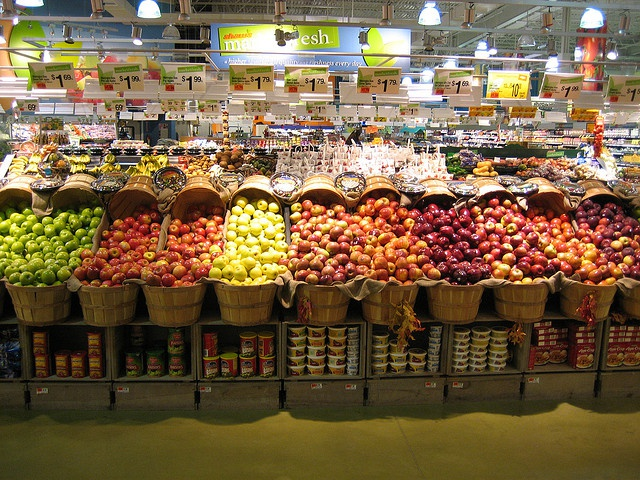Describe the objects in this image and their specific colors. I can see apple in gray, maroon, brown, and black tones, apple in gray, maroon, black, brown, and red tones, apple in gray, olive, black, and yellow tones, apple in gray, brown, red, maroon, and orange tones, and apple in gray, maroon, brown, black, and salmon tones in this image. 